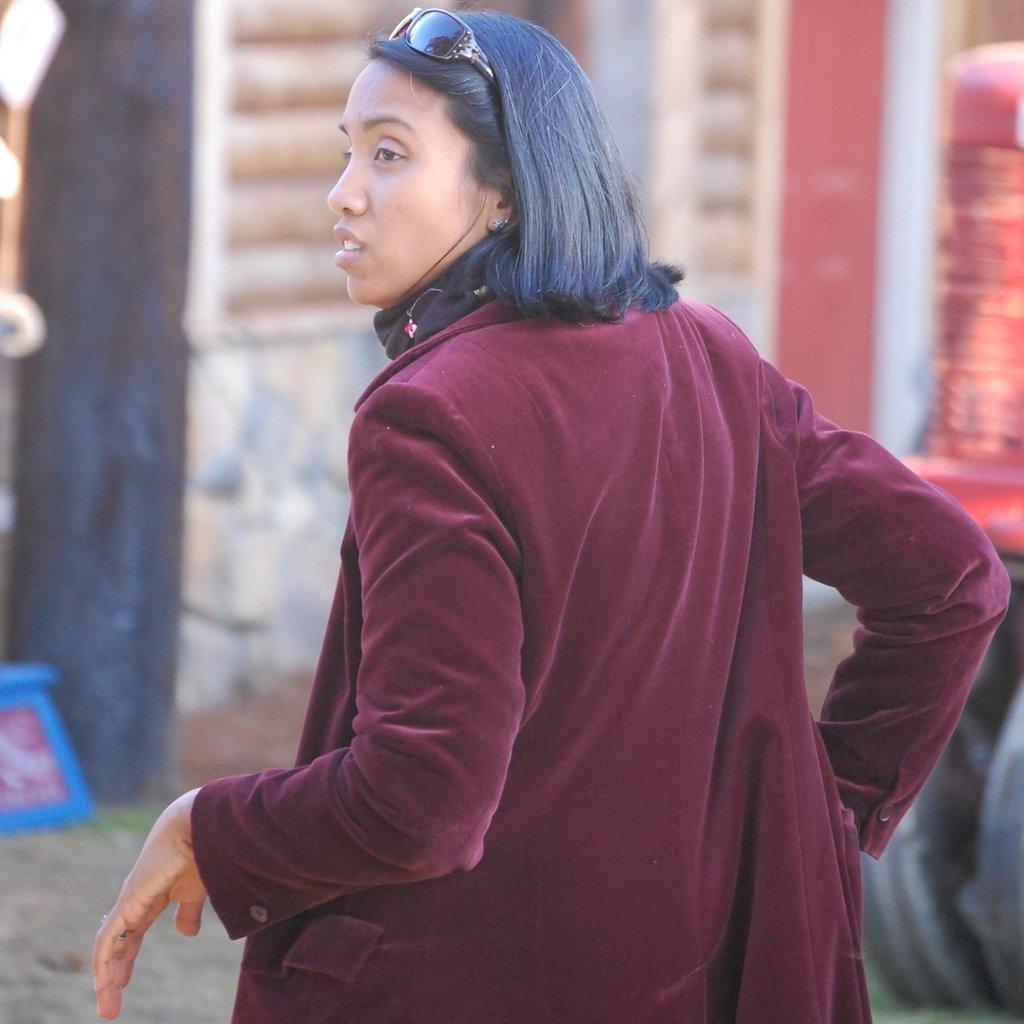Who is the main subject in the image? There is a woman in the image. What is the woman wearing on her face? The woman is wearing goggles. What can be observed in front of the woman? There are blurred objects in front of the woman. What type of produce can be seen growing in the image? There is no produce visible in the image; it primarily features a woman wearing goggles and blurred objects in front of her. 